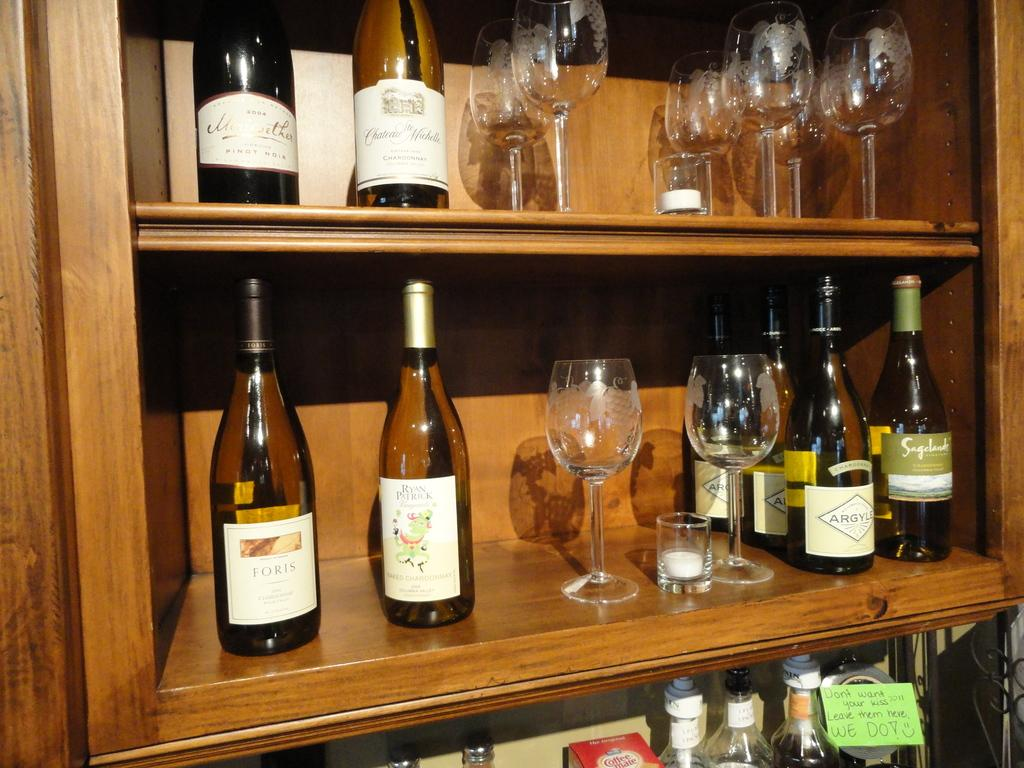<image>
Share a concise interpretation of the image provided. A wine shelf with bottles including Argyle Chardonnay. 